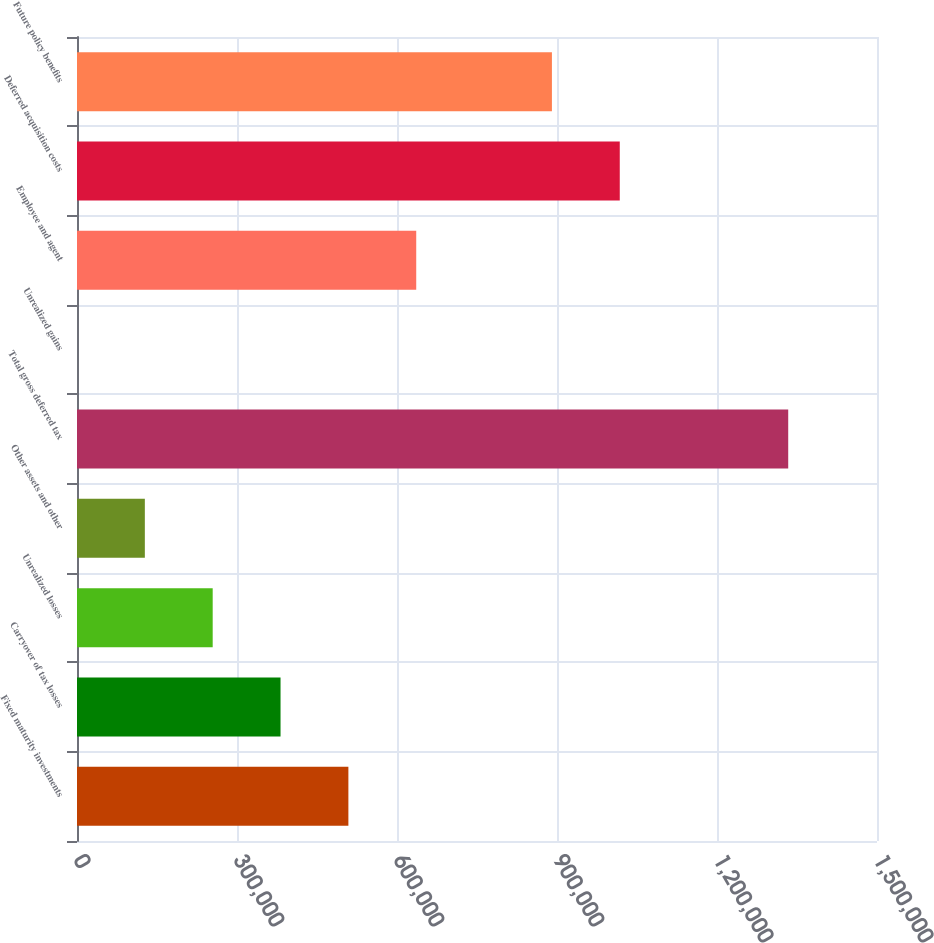<chart> <loc_0><loc_0><loc_500><loc_500><bar_chart><fcel>Fixed maturity investments<fcel>Carryover of tax losses<fcel>Unrealized losses<fcel>Other assets and other<fcel>Total gross deferred tax<fcel>Unrealized gains<fcel>Employee and agent<fcel>Deferred acquisition costs<fcel>Future policy benefits<nl><fcel>508845<fcel>381634<fcel>254423<fcel>127212<fcel>1.33353e+06<fcel>0.23<fcel>636057<fcel>1.01769e+06<fcel>890479<nl></chart> 